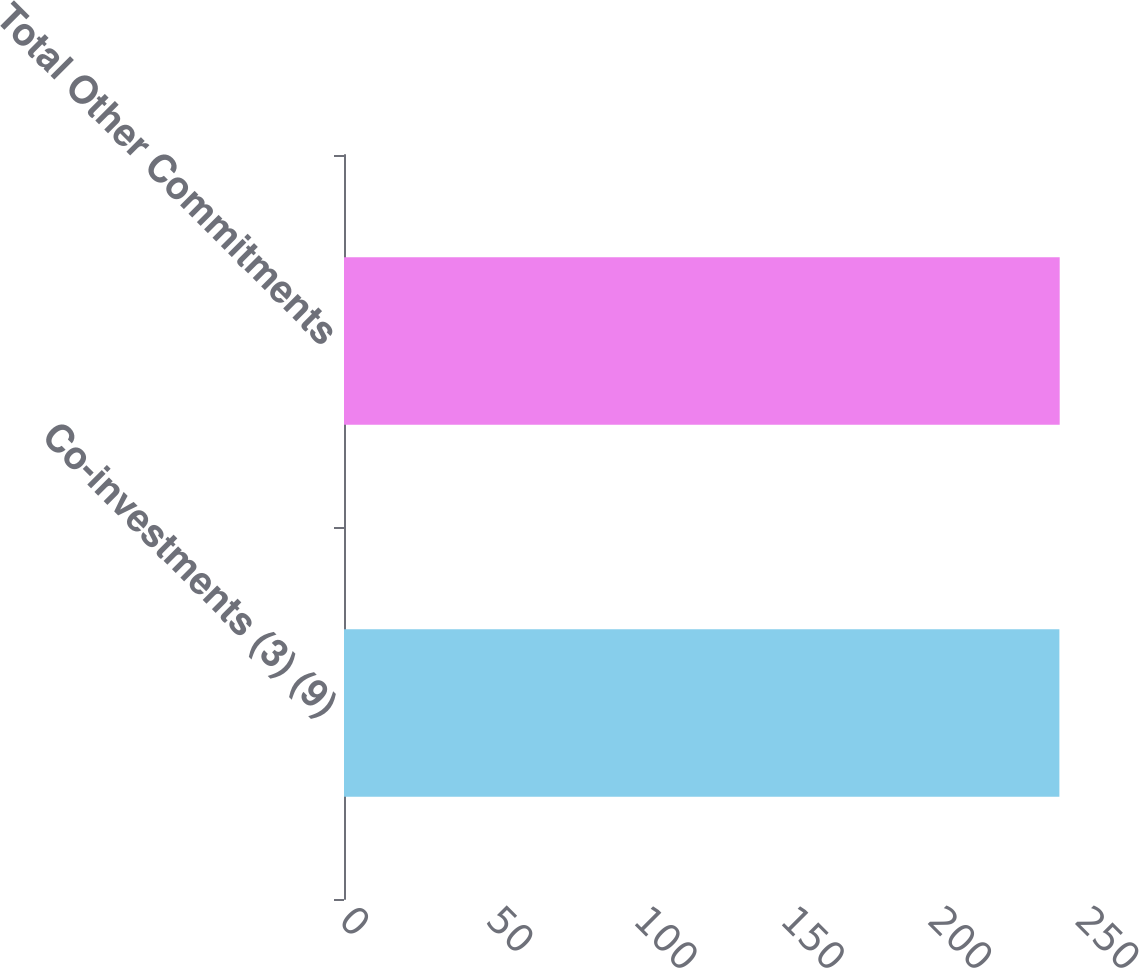Convert chart to OTSL. <chart><loc_0><loc_0><loc_500><loc_500><bar_chart><fcel>Co-investments (3) (9)<fcel>Total Other Commitments<nl><fcel>243<fcel>243.1<nl></chart> 